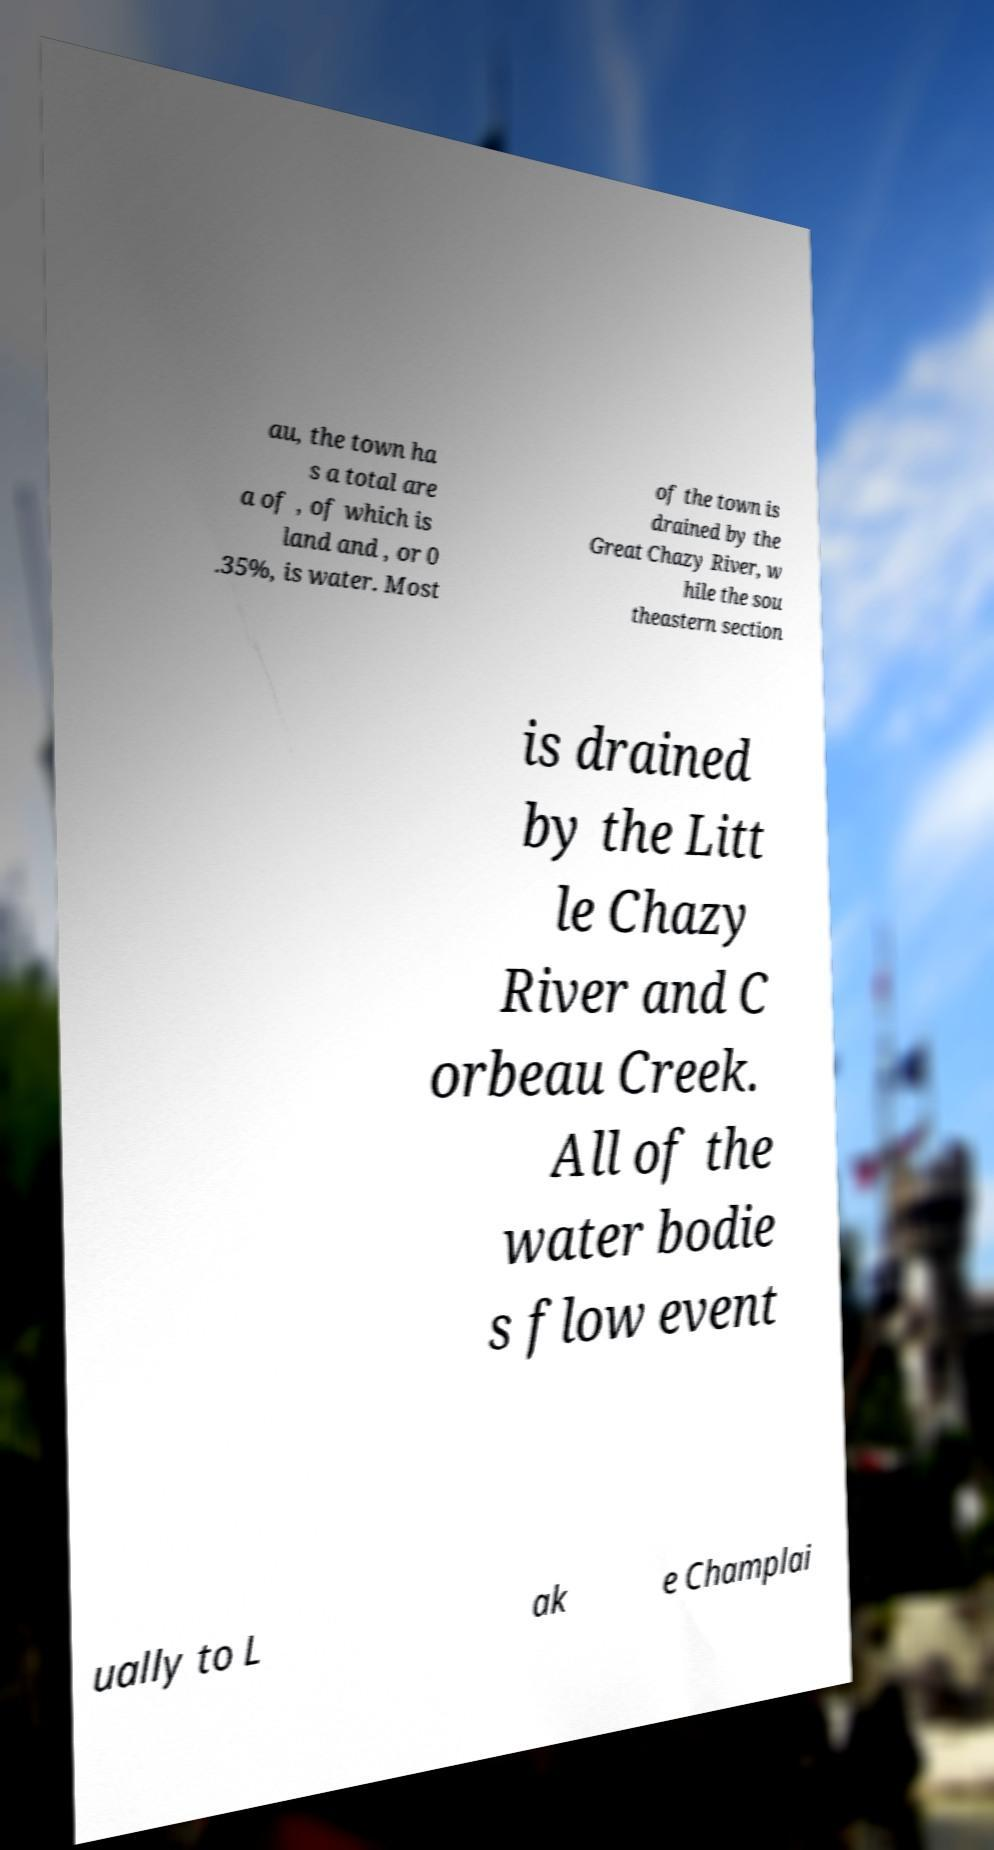Please identify and transcribe the text found in this image. au, the town ha s a total are a of , of which is land and , or 0 .35%, is water. Most of the town is drained by the Great Chazy River, w hile the sou theastern section is drained by the Litt le Chazy River and C orbeau Creek. All of the water bodie s flow event ually to L ak e Champlai 